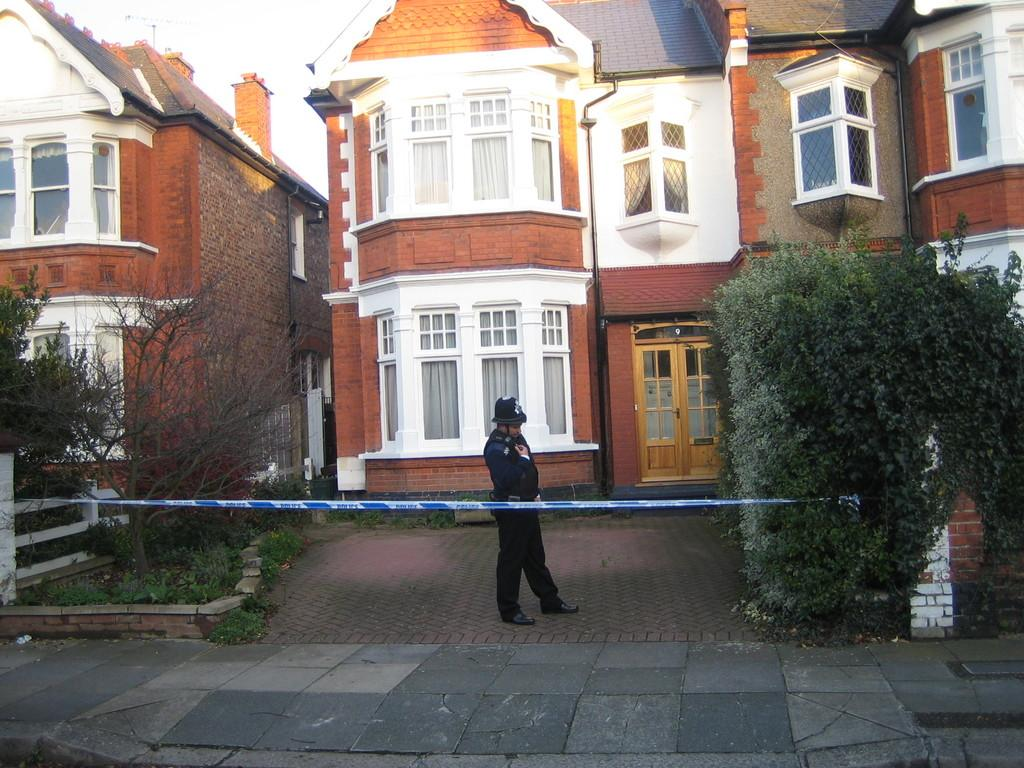What is the man in the image standing on? The man is standing on a flower. What can be seen in the background of the image? There are trees, plants, grass, buildings, windows, doors, an antenna, and the sky visible in the background of the image. What is the object tied in the image? The information provided does not specify what the tied object is. What type of wood can be seen in the image? There is no wood present in the image. How many buckets of water are visible in the image? There are no buckets of water visible in the image. 